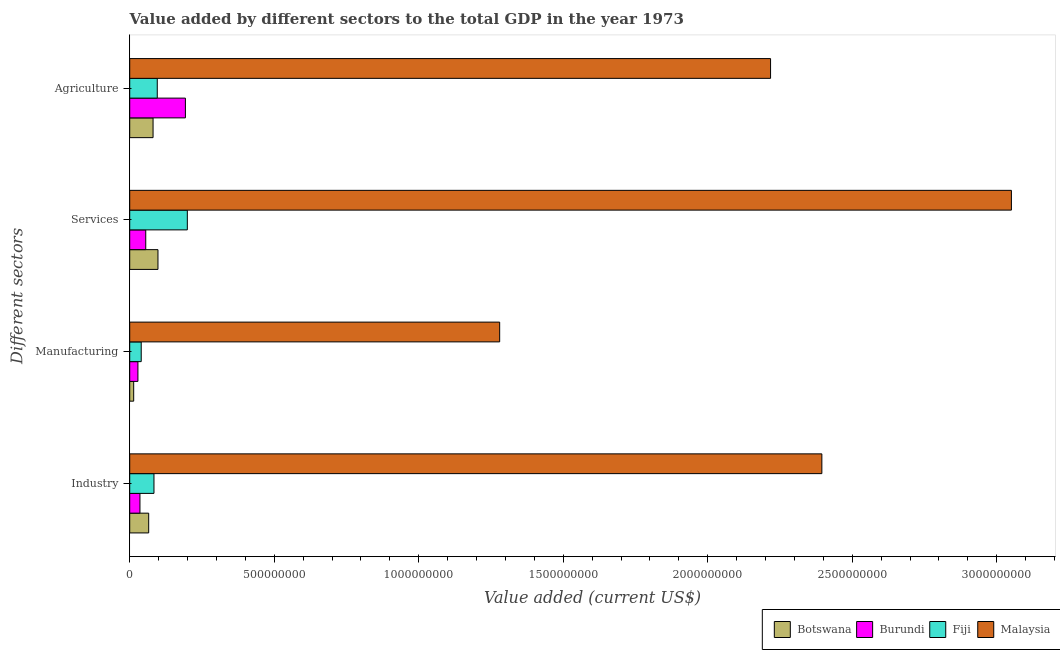How many groups of bars are there?
Your answer should be compact. 4. What is the label of the 4th group of bars from the top?
Your answer should be very brief. Industry. What is the value added by industrial sector in Botswana?
Keep it short and to the point. 6.56e+07. Across all countries, what is the maximum value added by agricultural sector?
Give a very brief answer. 2.22e+09. Across all countries, what is the minimum value added by industrial sector?
Offer a terse response. 3.54e+07. In which country was the value added by services sector maximum?
Your answer should be very brief. Malaysia. In which country was the value added by manufacturing sector minimum?
Offer a very short reply. Botswana. What is the total value added by manufacturing sector in the graph?
Provide a succinct answer. 1.36e+09. What is the difference between the value added by manufacturing sector in Burundi and that in Malaysia?
Your response must be concise. -1.25e+09. What is the difference between the value added by agricultural sector in Burundi and the value added by manufacturing sector in Botswana?
Provide a short and direct response. 1.79e+08. What is the average value added by industrial sector per country?
Offer a terse response. 6.45e+08. What is the difference between the value added by industrial sector and value added by services sector in Fiji?
Provide a short and direct response. -1.15e+08. What is the ratio of the value added by manufacturing sector in Fiji to that in Botswana?
Provide a succinct answer. 2.91. Is the value added by manufacturing sector in Fiji less than that in Burundi?
Ensure brevity in your answer.  No. What is the difference between the highest and the second highest value added by manufacturing sector?
Provide a short and direct response. 1.24e+09. What is the difference between the highest and the lowest value added by manufacturing sector?
Give a very brief answer. 1.27e+09. Is it the case that in every country, the sum of the value added by industrial sector and value added by services sector is greater than the sum of value added by manufacturing sector and value added by agricultural sector?
Your response must be concise. Yes. What does the 2nd bar from the top in Industry represents?
Keep it short and to the point. Fiji. What does the 4th bar from the bottom in Manufacturing represents?
Offer a terse response. Malaysia. Is it the case that in every country, the sum of the value added by industrial sector and value added by manufacturing sector is greater than the value added by services sector?
Offer a terse response. No. How many bars are there?
Provide a short and direct response. 16. Are the values on the major ticks of X-axis written in scientific E-notation?
Offer a terse response. No. Does the graph contain any zero values?
Make the answer very short. No. How are the legend labels stacked?
Your answer should be very brief. Horizontal. What is the title of the graph?
Provide a succinct answer. Value added by different sectors to the total GDP in the year 1973. What is the label or title of the X-axis?
Your answer should be very brief. Value added (current US$). What is the label or title of the Y-axis?
Your answer should be very brief. Different sectors. What is the Value added (current US$) of Botswana in Industry?
Provide a short and direct response. 6.56e+07. What is the Value added (current US$) in Burundi in Industry?
Your answer should be compact. 3.54e+07. What is the Value added (current US$) in Fiji in Industry?
Provide a succinct answer. 8.39e+07. What is the Value added (current US$) in Malaysia in Industry?
Keep it short and to the point. 2.39e+09. What is the Value added (current US$) in Botswana in Manufacturing?
Offer a very short reply. 1.37e+07. What is the Value added (current US$) of Burundi in Manufacturing?
Your answer should be compact. 2.84e+07. What is the Value added (current US$) of Fiji in Manufacturing?
Your answer should be very brief. 3.98e+07. What is the Value added (current US$) in Malaysia in Manufacturing?
Your response must be concise. 1.28e+09. What is the Value added (current US$) in Botswana in Services?
Keep it short and to the point. 9.78e+07. What is the Value added (current US$) in Burundi in Services?
Give a very brief answer. 5.55e+07. What is the Value added (current US$) of Fiji in Services?
Your answer should be compact. 1.99e+08. What is the Value added (current US$) of Malaysia in Services?
Make the answer very short. 3.05e+09. What is the Value added (current US$) of Botswana in Agriculture?
Ensure brevity in your answer.  8.08e+07. What is the Value added (current US$) in Burundi in Agriculture?
Provide a succinct answer. 1.93e+08. What is the Value added (current US$) of Fiji in Agriculture?
Your answer should be compact. 9.53e+07. What is the Value added (current US$) of Malaysia in Agriculture?
Your answer should be very brief. 2.22e+09. Across all Different sectors, what is the maximum Value added (current US$) of Botswana?
Provide a succinct answer. 9.78e+07. Across all Different sectors, what is the maximum Value added (current US$) of Burundi?
Ensure brevity in your answer.  1.93e+08. Across all Different sectors, what is the maximum Value added (current US$) in Fiji?
Provide a succinct answer. 1.99e+08. Across all Different sectors, what is the maximum Value added (current US$) of Malaysia?
Offer a very short reply. 3.05e+09. Across all Different sectors, what is the minimum Value added (current US$) of Botswana?
Give a very brief answer. 1.37e+07. Across all Different sectors, what is the minimum Value added (current US$) of Burundi?
Give a very brief answer. 2.84e+07. Across all Different sectors, what is the minimum Value added (current US$) of Fiji?
Ensure brevity in your answer.  3.98e+07. Across all Different sectors, what is the minimum Value added (current US$) of Malaysia?
Ensure brevity in your answer.  1.28e+09. What is the total Value added (current US$) in Botswana in the graph?
Keep it short and to the point. 2.58e+08. What is the total Value added (current US$) in Burundi in the graph?
Provide a succinct answer. 3.12e+08. What is the total Value added (current US$) of Fiji in the graph?
Offer a terse response. 4.18e+08. What is the total Value added (current US$) of Malaysia in the graph?
Your response must be concise. 8.94e+09. What is the difference between the Value added (current US$) in Botswana in Industry and that in Manufacturing?
Offer a very short reply. 5.19e+07. What is the difference between the Value added (current US$) in Burundi in Industry and that in Manufacturing?
Ensure brevity in your answer.  7.00e+06. What is the difference between the Value added (current US$) of Fiji in Industry and that in Manufacturing?
Give a very brief answer. 4.41e+07. What is the difference between the Value added (current US$) of Malaysia in Industry and that in Manufacturing?
Offer a terse response. 1.11e+09. What is the difference between the Value added (current US$) of Botswana in Industry and that in Services?
Make the answer very short. -3.21e+07. What is the difference between the Value added (current US$) in Burundi in Industry and that in Services?
Offer a very short reply. -2.01e+07. What is the difference between the Value added (current US$) in Fiji in Industry and that in Services?
Your answer should be very brief. -1.15e+08. What is the difference between the Value added (current US$) of Malaysia in Industry and that in Services?
Your response must be concise. -6.56e+08. What is the difference between the Value added (current US$) in Botswana in Industry and that in Agriculture?
Your response must be concise. -1.51e+07. What is the difference between the Value added (current US$) in Burundi in Industry and that in Agriculture?
Provide a succinct answer. -1.57e+08. What is the difference between the Value added (current US$) in Fiji in Industry and that in Agriculture?
Keep it short and to the point. -1.15e+07. What is the difference between the Value added (current US$) of Malaysia in Industry and that in Agriculture?
Ensure brevity in your answer.  1.77e+08. What is the difference between the Value added (current US$) in Botswana in Manufacturing and that in Services?
Offer a terse response. -8.41e+07. What is the difference between the Value added (current US$) in Burundi in Manufacturing and that in Services?
Your answer should be compact. -2.71e+07. What is the difference between the Value added (current US$) in Fiji in Manufacturing and that in Services?
Keep it short and to the point. -1.60e+08. What is the difference between the Value added (current US$) in Malaysia in Manufacturing and that in Services?
Provide a short and direct response. -1.77e+09. What is the difference between the Value added (current US$) in Botswana in Manufacturing and that in Agriculture?
Make the answer very short. -6.71e+07. What is the difference between the Value added (current US$) in Burundi in Manufacturing and that in Agriculture?
Make the answer very short. -1.64e+08. What is the difference between the Value added (current US$) of Fiji in Manufacturing and that in Agriculture?
Keep it short and to the point. -5.55e+07. What is the difference between the Value added (current US$) of Malaysia in Manufacturing and that in Agriculture?
Offer a very short reply. -9.37e+08. What is the difference between the Value added (current US$) of Botswana in Services and that in Agriculture?
Offer a terse response. 1.70e+07. What is the difference between the Value added (current US$) in Burundi in Services and that in Agriculture?
Your answer should be compact. -1.37e+08. What is the difference between the Value added (current US$) in Fiji in Services and that in Agriculture?
Make the answer very short. 1.04e+08. What is the difference between the Value added (current US$) in Malaysia in Services and that in Agriculture?
Offer a terse response. 8.33e+08. What is the difference between the Value added (current US$) in Botswana in Industry and the Value added (current US$) in Burundi in Manufacturing?
Your answer should be very brief. 3.72e+07. What is the difference between the Value added (current US$) in Botswana in Industry and the Value added (current US$) in Fiji in Manufacturing?
Provide a short and direct response. 2.58e+07. What is the difference between the Value added (current US$) in Botswana in Industry and the Value added (current US$) in Malaysia in Manufacturing?
Offer a very short reply. -1.21e+09. What is the difference between the Value added (current US$) in Burundi in Industry and the Value added (current US$) in Fiji in Manufacturing?
Your answer should be compact. -4.41e+06. What is the difference between the Value added (current US$) of Burundi in Industry and the Value added (current US$) of Malaysia in Manufacturing?
Your answer should be compact. -1.24e+09. What is the difference between the Value added (current US$) in Fiji in Industry and the Value added (current US$) in Malaysia in Manufacturing?
Your response must be concise. -1.20e+09. What is the difference between the Value added (current US$) of Botswana in Industry and the Value added (current US$) of Burundi in Services?
Provide a short and direct response. 1.01e+07. What is the difference between the Value added (current US$) in Botswana in Industry and the Value added (current US$) in Fiji in Services?
Your response must be concise. -1.34e+08. What is the difference between the Value added (current US$) in Botswana in Industry and the Value added (current US$) in Malaysia in Services?
Your answer should be very brief. -2.99e+09. What is the difference between the Value added (current US$) of Burundi in Industry and the Value added (current US$) of Fiji in Services?
Your answer should be compact. -1.64e+08. What is the difference between the Value added (current US$) in Burundi in Industry and the Value added (current US$) in Malaysia in Services?
Provide a short and direct response. -3.02e+09. What is the difference between the Value added (current US$) of Fiji in Industry and the Value added (current US$) of Malaysia in Services?
Your answer should be very brief. -2.97e+09. What is the difference between the Value added (current US$) of Botswana in Industry and the Value added (current US$) of Burundi in Agriculture?
Your response must be concise. -1.27e+08. What is the difference between the Value added (current US$) of Botswana in Industry and the Value added (current US$) of Fiji in Agriculture?
Your answer should be very brief. -2.97e+07. What is the difference between the Value added (current US$) in Botswana in Industry and the Value added (current US$) in Malaysia in Agriculture?
Ensure brevity in your answer.  -2.15e+09. What is the difference between the Value added (current US$) in Burundi in Industry and the Value added (current US$) in Fiji in Agriculture?
Make the answer very short. -5.99e+07. What is the difference between the Value added (current US$) in Burundi in Industry and the Value added (current US$) in Malaysia in Agriculture?
Provide a short and direct response. -2.18e+09. What is the difference between the Value added (current US$) of Fiji in Industry and the Value added (current US$) of Malaysia in Agriculture?
Provide a short and direct response. -2.13e+09. What is the difference between the Value added (current US$) in Botswana in Manufacturing and the Value added (current US$) in Burundi in Services?
Offer a terse response. -4.18e+07. What is the difference between the Value added (current US$) of Botswana in Manufacturing and the Value added (current US$) of Fiji in Services?
Offer a very short reply. -1.86e+08. What is the difference between the Value added (current US$) in Botswana in Manufacturing and the Value added (current US$) in Malaysia in Services?
Keep it short and to the point. -3.04e+09. What is the difference between the Value added (current US$) in Burundi in Manufacturing and the Value added (current US$) in Fiji in Services?
Offer a terse response. -1.71e+08. What is the difference between the Value added (current US$) in Burundi in Manufacturing and the Value added (current US$) in Malaysia in Services?
Make the answer very short. -3.02e+09. What is the difference between the Value added (current US$) of Fiji in Manufacturing and the Value added (current US$) of Malaysia in Services?
Ensure brevity in your answer.  -3.01e+09. What is the difference between the Value added (current US$) of Botswana in Manufacturing and the Value added (current US$) of Burundi in Agriculture?
Keep it short and to the point. -1.79e+08. What is the difference between the Value added (current US$) in Botswana in Manufacturing and the Value added (current US$) in Fiji in Agriculture?
Keep it short and to the point. -8.16e+07. What is the difference between the Value added (current US$) of Botswana in Manufacturing and the Value added (current US$) of Malaysia in Agriculture?
Offer a very short reply. -2.20e+09. What is the difference between the Value added (current US$) of Burundi in Manufacturing and the Value added (current US$) of Fiji in Agriculture?
Your answer should be very brief. -6.69e+07. What is the difference between the Value added (current US$) in Burundi in Manufacturing and the Value added (current US$) in Malaysia in Agriculture?
Your answer should be very brief. -2.19e+09. What is the difference between the Value added (current US$) of Fiji in Manufacturing and the Value added (current US$) of Malaysia in Agriculture?
Provide a short and direct response. -2.18e+09. What is the difference between the Value added (current US$) in Botswana in Services and the Value added (current US$) in Burundi in Agriculture?
Offer a terse response. -9.49e+07. What is the difference between the Value added (current US$) in Botswana in Services and the Value added (current US$) in Fiji in Agriculture?
Offer a terse response. 2.43e+06. What is the difference between the Value added (current US$) in Botswana in Services and the Value added (current US$) in Malaysia in Agriculture?
Keep it short and to the point. -2.12e+09. What is the difference between the Value added (current US$) of Burundi in Services and the Value added (current US$) of Fiji in Agriculture?
Ensure brevity in your answer.  -3.98e+07. What is the difference between the Value added (current US$) in Burundi in Services and the Value added (current US$) in Malaysia in Agriculture?
Provide a succinct answer. -2.16e+09. What is the difference between the Value added (current US$) in Fiji in Services and the Value added (current US$) in Malaysia in Agriculture?
Make the answer very short. -2.02e+09. What is the average Value added (current US$) in Botswana per Different sectors?
Provide a succinct answer. 6.45e+07. What is the average Value added (current US$) in Burundi per Different sectors?
Ensure brevity in your answer.  7.80e+07. What is the average Value added (current US$) of Fiji per Different sectors?
Make the answer very short. 1.05e+08. What is the average Value added (current US$) of Malaysia per Different sectors?
Your answer should be very brief. 2.24e+09. What is the difference between the Value added (current US$) of Botswana and Value added (current US$) of Burundi in Industry?
Provide a short and direct response. 3.02e+07. What is the difference between the Value added (current US$) of Botswana and Value added (current US$) of Fiji in Industry?
Your answer should be very brief. -1.82e+07. What is the difference between the Value added (current US$) in Botswana and Value added (current US$) in Malaysia in Industry?
Give a very brief answer. -2.33e+09. What is the difference between the Value added (current US$) of Burundi and Value added (current US$) of Fiji in Industry?
Make the answer very short. -4.85e+07. What is the difference between the Value added (current US$) of Burundi and Value added (current US$) of Malaysia in Industry?
Make the answer very short. -2.36e+09. What is the difference between the Value added (current US$) in Fiji and Value added (current US$) in Malaysia in Industry?
Your response must be concise. -2.31e+09. What is the difference between the Value added (current US$) of Botswana and Value added (current US$) of Burundi in Manufacturing?
Give a very brief answer. -1.47e+07. What is the difference between the Value added (current US$) of Botswana and Value added (current US$) of Fiji in Manufacturing?
Your response must be concise. -2.61e+07. What is the difference between the Value added (current US$) in Botswana and Value added (current US$) in Malaysia in Manufacturing?
Your answer should be very brief. -1.27e+09. What is the difference between the Value added (current US$) in Burundi and Value added (current US$) in Fiji in Manufacturing?
Offer a terse response. -1.14e+07. What is the difference between the Value added (current US$) of Burundi and Value added (current US$) of Malaysia in Manufacturing?
Your answer should be compact. -1.25e+09. What is the difference between the Value added (current US$) in Fiji and Value added (current US$) in Malaysia in Manufacturing?
Offer a terse response. -1.24e+09. What is the difference between the Value added (current US$) of Botswana and Value added (current US$) of Burundi in Services?
Ensure brevity in your answer.  4.23e+07. What is the difference between the Value added (current US$) of Botswana and Value added (current US$) of Fiji in Services?
Keep it short and to the point. -1.02e+08. What is the difference between the Value added (current US$) in Botswana and Value added (current US$) in Malaysia in Services?
Make the answer very short. -2.95e+09. What is the difference between the Value added (current US$) in Burundi and Value added (current US$) in Fiji in Services?
Offer a very short reply. -1.44e+08. What is the difference between the Value added (current US$) in Burundi and Value added (current US$) in Malaysia in Services?
Offer a terse response. -3.00e+09. What is the difference between the Value added (current US$) in Fiji and Value added (current US$) in Malaysia in Services?
Provide a succinct answer. -2.85e+09. What is the difference between the Value added (current US$) of Botswana and Value added (current US$) of Burundi in Agriculture?
Offer a terse response. -1.12e+08. What is the difference between the Value added (current US$) of Botswana and Value added (current US$) of Fiji in Agriculture?
Offer a very short reply. -1.46e+07. What is the difference between the Value added (current US$) of Botswana and Value added (current US$) of Malaysia in Agriculture?
Offer a very short reply. -2.14e+09. What is the difference between the Value added (current US$) in Burundi and Value added (current US$) in Fiji in Agriculture?
Give a very brief answer. 9.74e+07. What is the difference between the Value added (current US$) in Burundi and Value added (current US$) in Malaysia in Agriculture?
Your answer should be compact. -2.02e+09. What is the difference between the Value added (current US$) of Fiji and Value added (current US$) of Malaysia in Agriculture?
Make the answer very short. -2.12e+09. What is the ratio of the Value added (current US$) in Botswana in Industry to that in Manufacturing?
Offer a very short reply. 4.79. What is the ratio of the Value added (current US$) in Burundi in Industry to that in Manufacturing?
Your response must be concise. 1.25. What is the ratio of the Value added (current US$) in Fiji in Industry to that in Manufacturing?
Your response must be concise. 2.11. What is the ratio of the Value added (current US$) in Malaysia in Industry to that in Manufacturing?
Give a very brief answer. 1.87. What is the ratio of the Value added (current US$) of Botswana in Industry to that in Services?
Keep it short and to the point. 0.67. What is the ratio of the Value added (current US$) in Burundi in Industry to that in Services?
Your answer should be compact. 0.64. What is the ratio of the Value added (current US$) of Fiji in Industry to that in Services?
Your response must be concise. 0.42. What is the ratio of the Value added (current US$) in Malaysia in Industry to that in Services?
Provide a short and direct response. 0.79. What is the ratio of the Value added (current US$) of Botswana in Industry to that in Agriculture?
Your answer should be very brief. 0.81. What is the ratio of the Value added (current US$) of Burundi in Industry to that in Agriculture?
Offer a terse response. 0.18. What is the ratio of the Value added (current US$) of Fiji in Industry to that in Agriculture?
Ensure brevity in your answer.  0.88. What is the ratio of the Value added (current US$) of Botswana in Manufacturing to that in Services?
Make the answer very short. 0.14. What is the ratio of the Value added (current US$) in Burundi in Manufacturing to that in Services?
Your answer should be very brief. 0.51. What is the ratio of the Value added (current US$) in Fiji in Manufacturing to that in Services?
Your answer should be compact. 0.2. What is the ratio of the Value added (current US$) of Malaysia in Manufacturing to that in Services?
Provide a short and direct response. 0.42. What is the ratio of the Value added (current US$) of Botswana in Manufacturing to that in Agriculture?
Your answer should be very brief. 0.17. What is the ratio of the Value added (current US$) of Burundi in Manufacturing to that in Agriculture?
Keep it short and to the point. 0.15. What is the ratio of the Value added (current US$) of Fiji in Manufacturing to that in Agriculture?
Offer a very short reply. 0.42. What is the ratio of the Value added (current US$) of Malaysia in Manufacturing to that in Agriculture?
Provide a short and direct response. 0.58. What is the ratio of the Value added (current US$) in Botswana in Services to that in Agriculture?
Keep it short and to the point. 1.21. What is the ratio of the Value added (current US$) in Burundi in Services to that in Agriculture?
Offer a terse response. 0.29. What is the ratio of the Value added (current US$) in Fiji in Services to that in Agriculture?
Offer a very short reply. 2.09. What is the ratio of the Value added (current US$) in Malaysia in Services to that in Agriculture?
Offer a very short reply. 1.38. What is the difference between the highest and the second highest Value added (current US$) in Botswana?
Offer a very short reply. 1.70e+07. What is the difference between the highest and the second highest Value added (current US$) of Burundi?
Keep it short and to the point. 1.37e+08. What is the difference between the highest and the second highest Value added (current US$) of Fiji?
Provide a succinct answer. 1.04e+08. What is the difference between the highest and the second highest Value added (current US$) of Malaysia?
Your response must be concise. 6.56e+08. What is the difference between the highest and the lowest Value added (current US$) in Botswana?
Your response must be concise. 8.41e+07. What is the difference between the highest and the lowest Value added (current US$) in Burundi?
Make the answer very short. 1.64e+08. What is the difference between the highest and the lowest Value added (current US$) in Fiji?
Keep it short and to the point. 1.60e+08. What is the difference between the highest and the lowest Value added (current US$) in Malaysia?
Provide a short and direct response. 1.77e+09. 